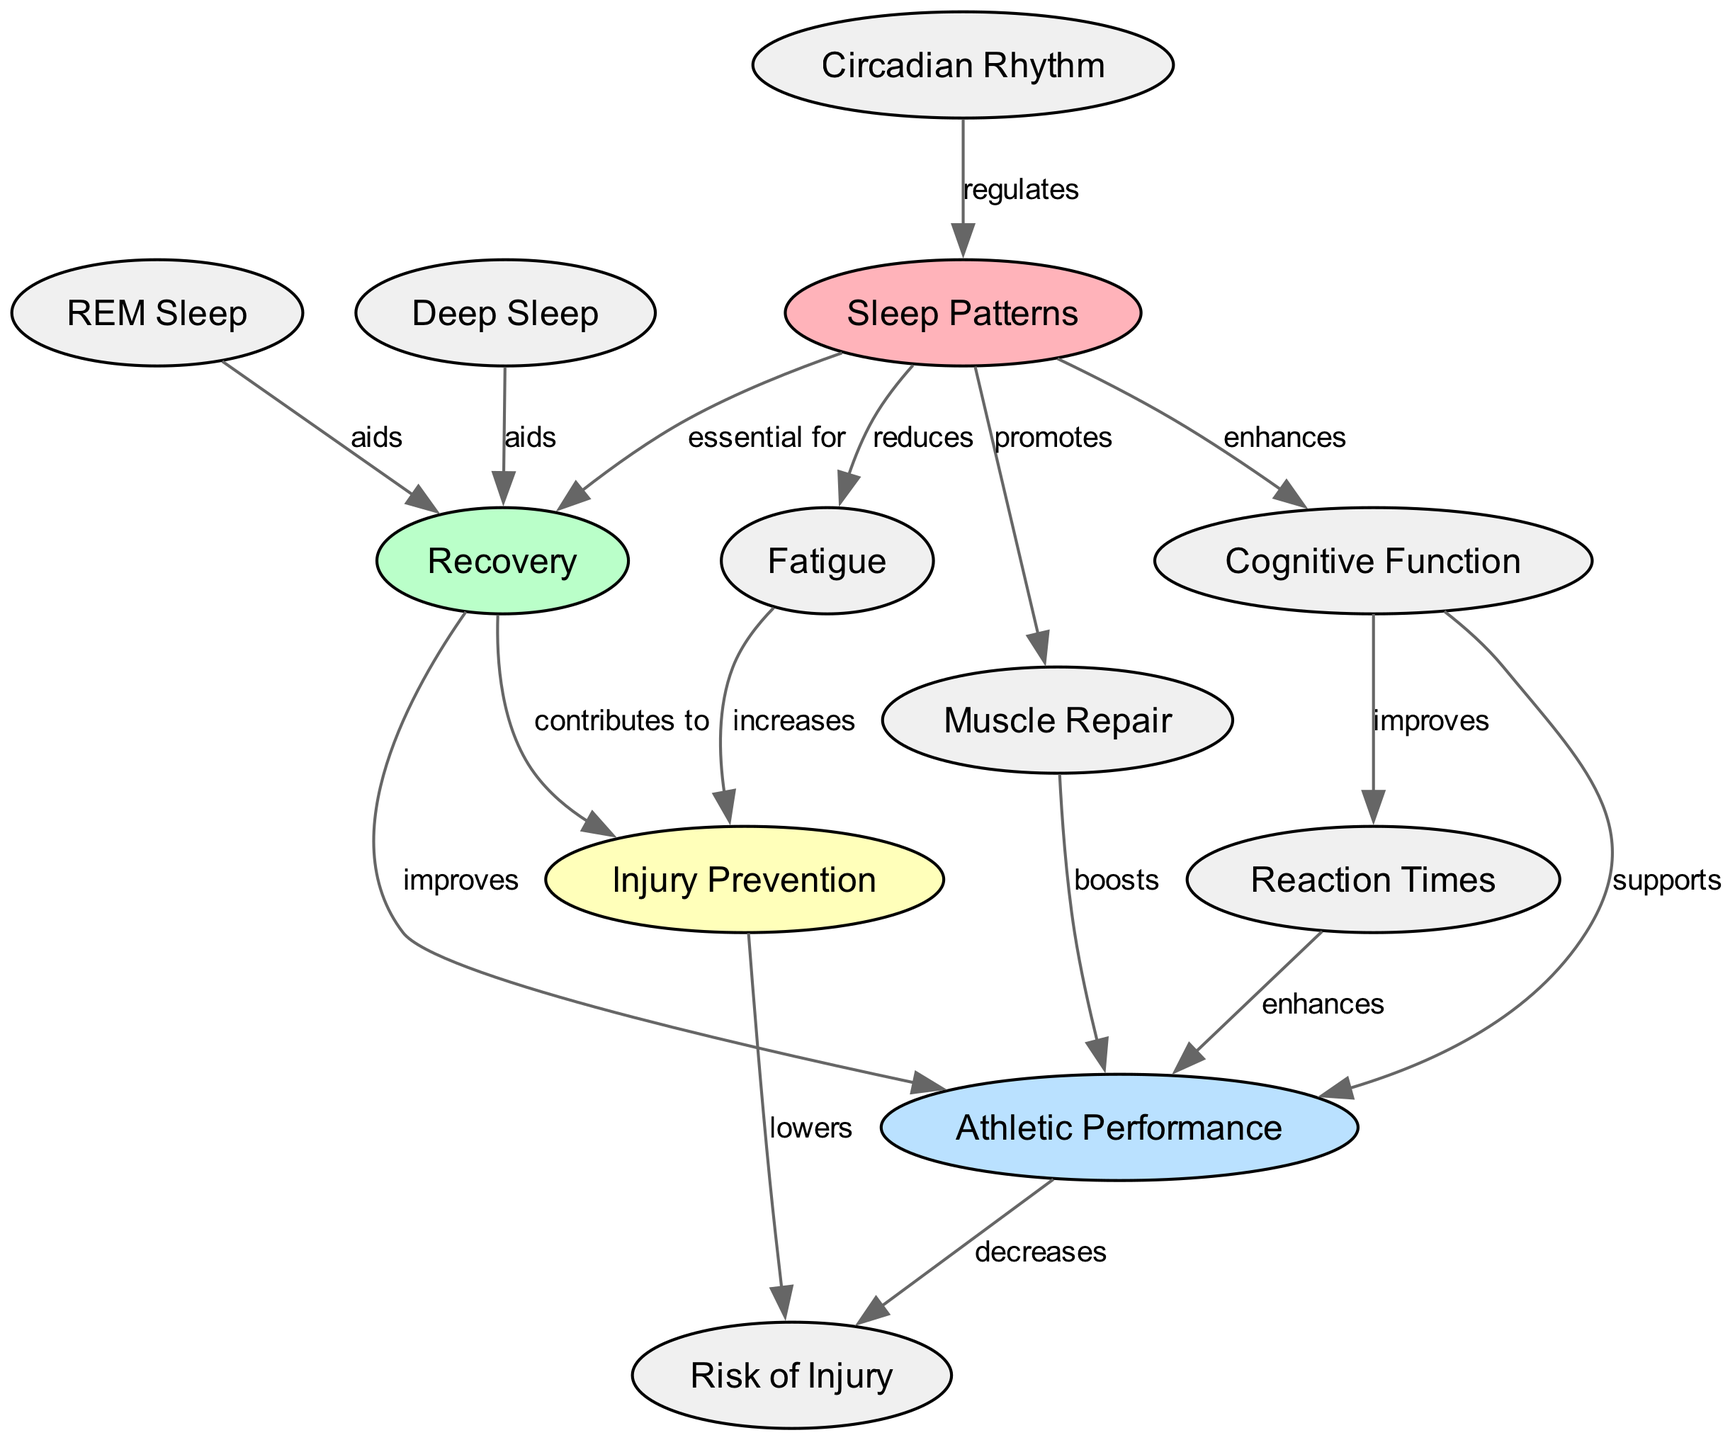What is the primary node in the diagram? The primary node in the diagram is "Sleep Patterns," which is the starting point for other connections in the diagram. It indicates the foundational element for understanding recovery and related factors.
Answer: Sleep Patterns How many nodes are present in the diagram? There are a total of 12 nodes represented in the diagram, each corresponding to different concepts related to sleep, recovery, performance, and injury prevention.
Answer: 12 What does "Sleep Patterns" promote according to the diagram? "Sleep Patterns" promotes "Muscle Repair," which suggests that adequate sleep is benefitting muscle recovery processes after athletic activities, highlighting a key relationship in the context of performance and recovery.
Answer: Muscle Repair Which node is linked to "Cognitive Function"? The node "Cognitive Function" is linked to "Sleep Patterns" in the diagram, which indicates that sleep has a positive impact on cognitive abilities and mental performance in athletes.
Answer: Sleep Patterns What does "Recovery" improve according to the diagram? According to the diagram, "Recovery" improves "Athletic Performance," showing the direct impact of effective recovery strategies on the performance levels of athletes.
Answer: Athletic Performance How does "Deep Sleep" aid the process in the diagram? "Deep Sleep" aids "Recovery," indicating that obtaining adequate deep sleep is crucial for recovering from physical exertion and provides essential restorative benefits necessary for athletic performance.
Answer: Recovery What is increased by "Fatigue" in the diagram? In the diagram, "Fatigue" increases the "Risk of Injury," emphasizing the importance of managing fatigue levels in athletes to prevent injuries during performance and training.
Answer: Risk of Injury What relationship does "Circadian Rhythm" have with "Sleep Patterns"? The relationship in the diagram indicates that "Circadian Rhythm" regulates "Sleep Patterns," which underscores the timing of sleep in relation to the body’s biological clock for optimal recovery and performance.
Answer: regulates Which node contributes to "Injury Prevention"? The node "Recovery" contributes to "Injury Prevention" according to the diagram, indicating that proper recovery processes lessen the likelihood of sustaining injuries in athletes.
Answer: Recovery 